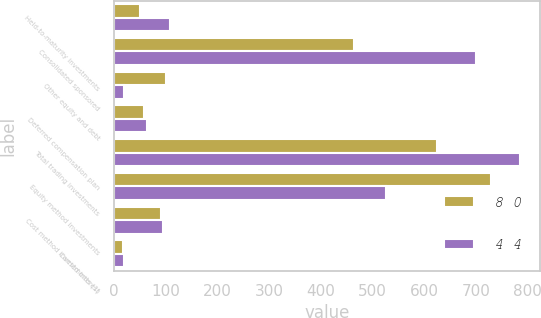Convert chart. <chart><loc_0><loc_0><loc_500><loc_500><stacked_bar_chart><ecel><fcel>Held-to-maturity investments<fcel>Consolidated sponsored<fcel>Other equity and debt<fcel>Deferred compensation plan<fcel>Total trading investments<fcel>Equity method investments<fcel>Cost method investments (1)<fcel>Carried interest<nl><fcel>8 0<fcel>51<fcel>465<fcel>101<fcel>59<fcel>625<fcel>730<fcel>91<fcel>18<nl><fcel>4 4<fcel>108<fcel>700<fcel>20<fcel>65<fcel>785<fcel>527<fcel>95<fcel>19<nl></chart> 